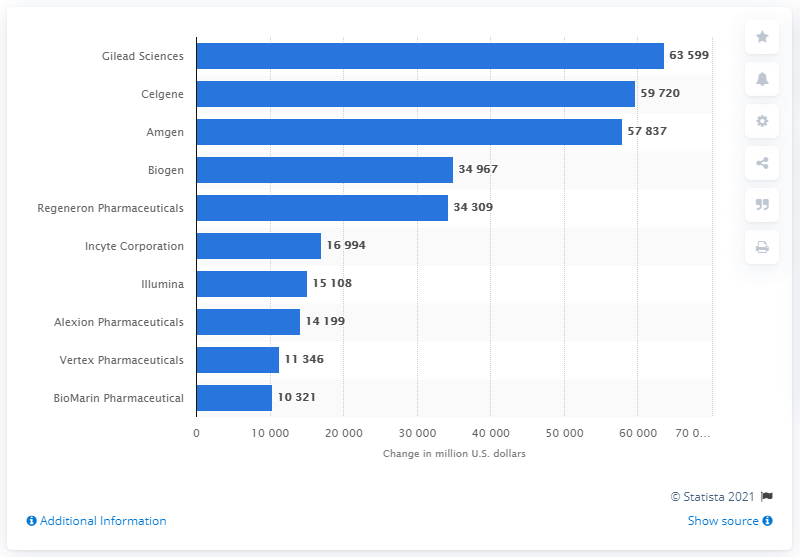List a handful of essential elements in this visual. Amgen's market capitalization increased by an estimated 5,783.7 between 2012 and 2016. 